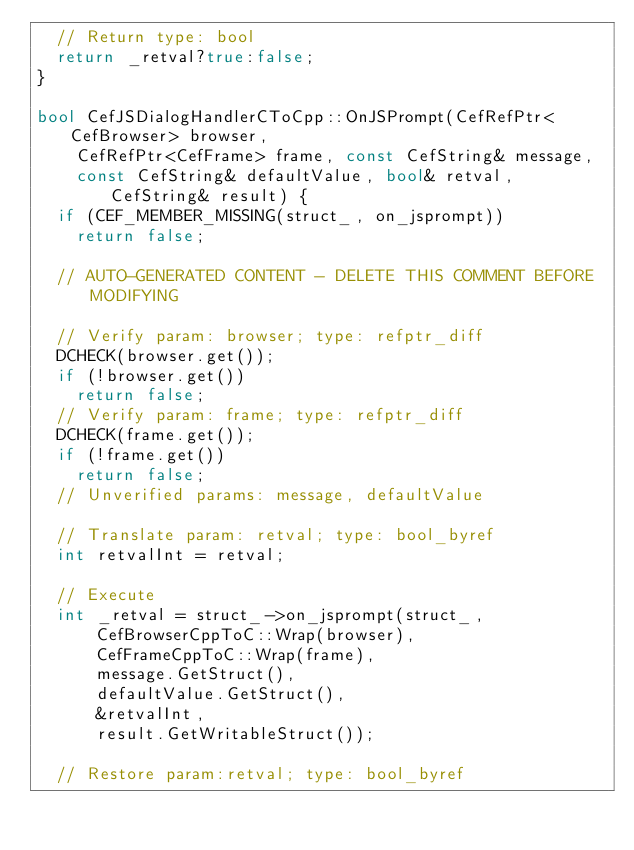<code> <loc_0><loc_0><loc_500><loc_500><_C++_>  // Return type: bool
  return _retval?true:false;
}

bool CefJSDialogHandlerCToCpp::OnJSPrompt(CefRefPtr<CefBrowser> browser,
    CefRefPtr<CefFrame> frame, const CefString& message,
    const CefString& defaultValue, bool& retval, CefString& result) {
  if (CEF_MEMBER_MISSING(struct_, on_jsprompt))
    return false;

  // AUTO-GENERATED CONTENT - DELETE THIS COMMENT BEFORE MODIFYING

  // Verify param: browser; type: refptr_diff
  DCHECK(browser.get());
  if (!browser.get())
    return false;
  // Verify param: frame; type: refptr_diff
  DCHECK(frame.get());
  if (!frame.get())
    return false;
  // Unverified params: message, defaultValue

  // Translate param: retval; type: bool_byref
  int retvalInt = retval;

  // Execute
  int _retval = struct_->on_jsprompt(struct_,
      CefBrowserCppToC::Wrap(browser),
      CefFrameCppToC::Wrap(frame),
      message.GetStruct(),
      defaultValue.GetStruct(),
      &retvalInt,
      result.GetWritableStruct());

  // Restore param:retval; type: bool_byref</code> 